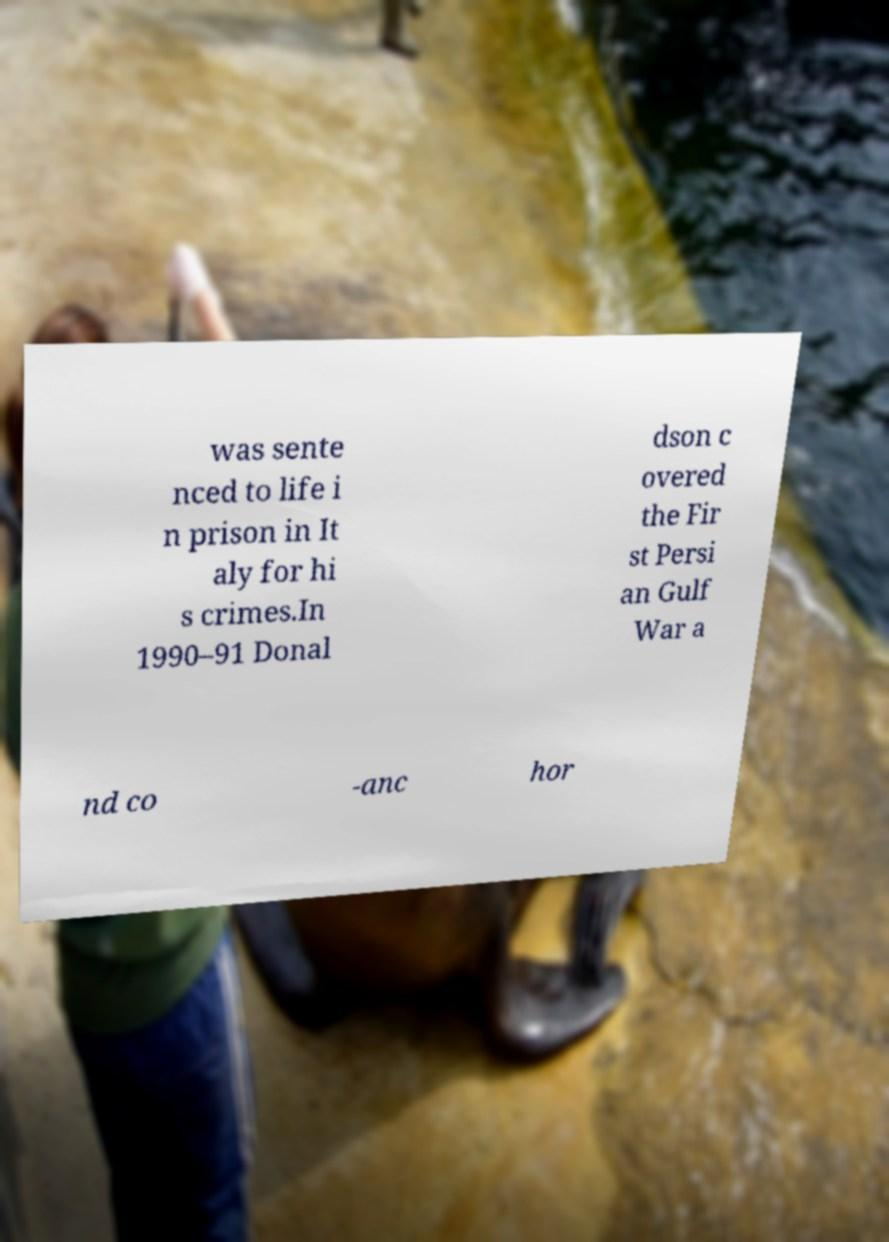Can you accurately transcribe the text from the provided image for me? was sente nced to life i n prison in It aly for hi s crimes.In 1990–91 Donal dson c overed the Fir st Persi an Gulf War a nd co -anc hor 